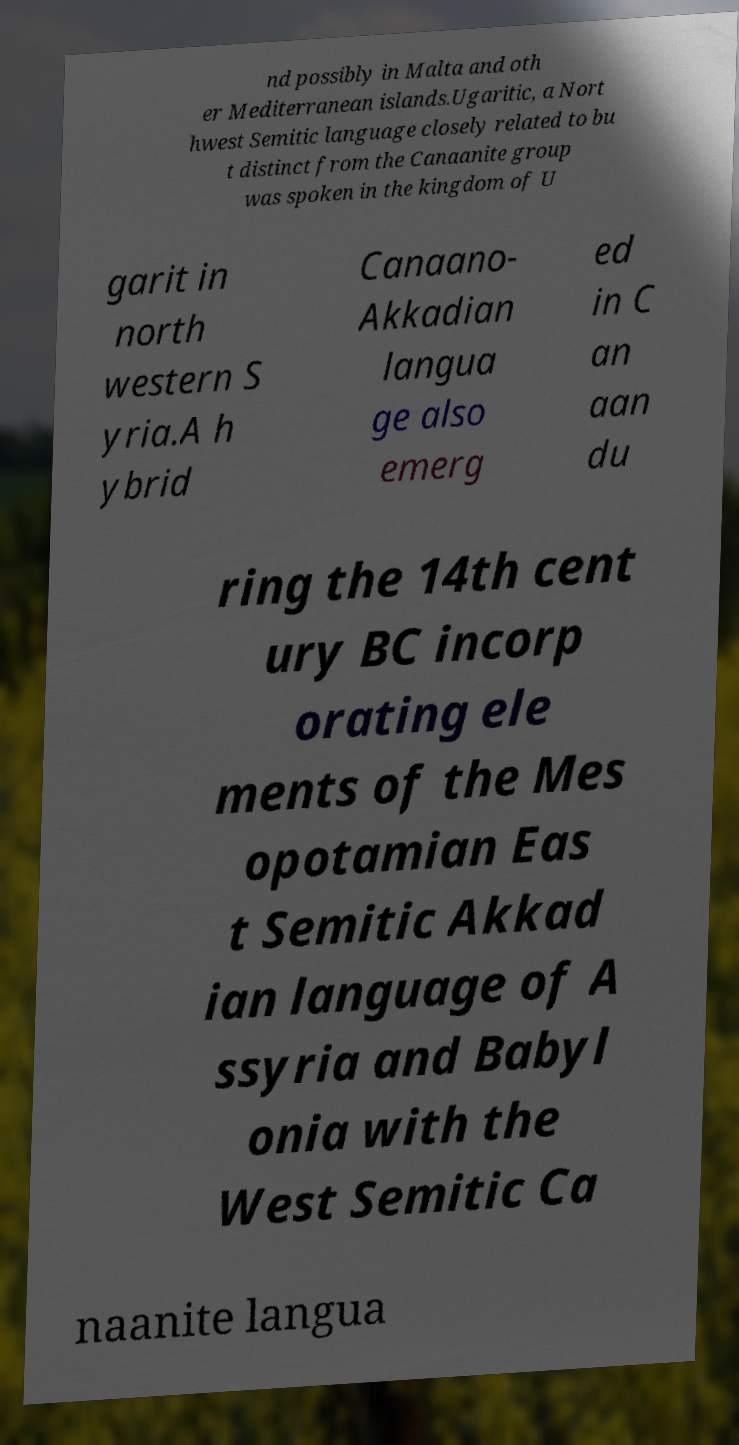Can you read and provide the text displayed in the image?This photo seems to have some interesting text. Can you extract and type it out for me? nd possibly in Malta and oth er Mediterranean islands.Ugaritic, a Nort hwest Semitic language closely related to bu t distinct from the Canaanite group was spoken in the kingdom of U garit in north western S yria.A h ybrid Canaano- Akkadian langua ge also emerg ed in C an aan du ring the 14th cent ury BC incorp orating ele ments of the Mes opotamian Eas t Semitic Akkad ian language of A ssyria and Babyl onia with the West Semitic Ca naanite langua 